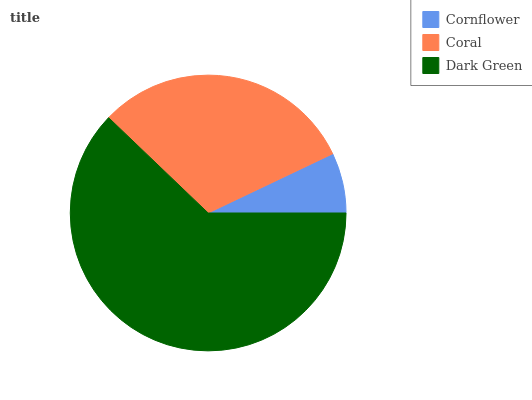Is Cornflower the minimum?
Answer yes or no. Yes. Is Dark Green the maximum?
Answer yes or no. Yes. Is Coral the minimum?
Answer yes or no. No. Is Coral the maximum?
Answer yes or no. No. Is Coral greater than Cornflower?
Answer yes or no. Yes. Is Cornflower less than Coral?
Answer yes or no. Yes. Is Cornflower greater than Coral?
Answer yes or no. No. Is Coral less than Cornflower?
Answer yes or no. No. Is Coral the high median?
Answer yes or no. Yes. Is Coral the low median?
Answer yes or no. Yes. Is Cornflower the high median?
Answer yes or no. No. Is Cornflower the low median?
Answer yes or no. No. 